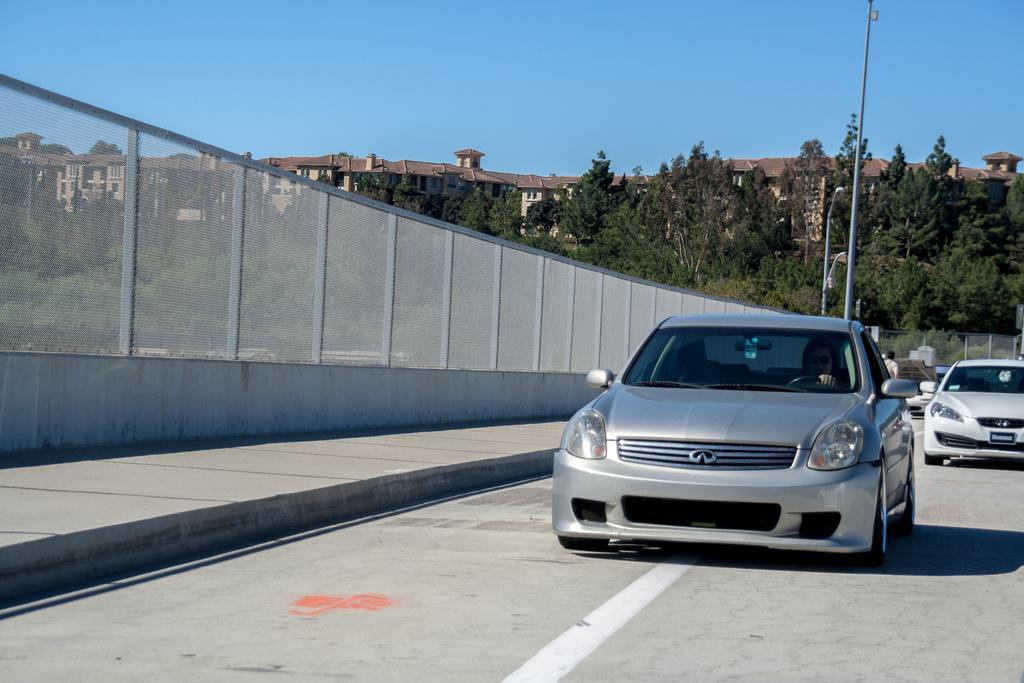Could you give a brief overview of what you see in this image? This image is clicked on the road. There are cars moving on the road. Beside the road there is a walkway. Beside the walkway there is a railing. In the background there are buildings and trees. There are street light poles on the walkway. At the top there is the sky. 